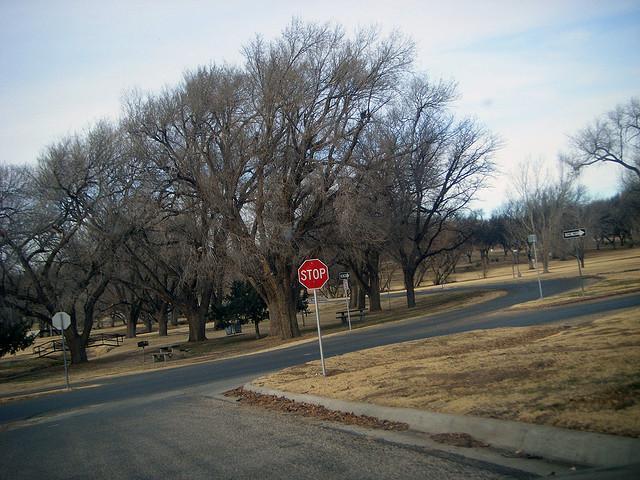How many roads are there?
Give a very brief answer. 3. How many zebra are there?
Give a very brief answer. 0. 